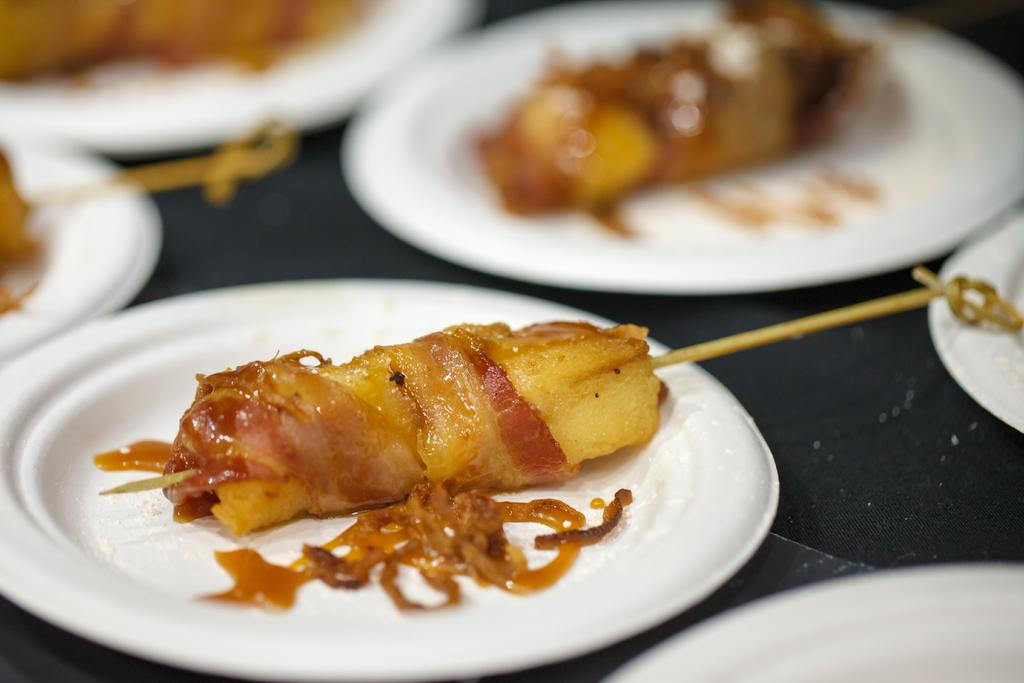What type of items can be seen in the image? There are eatables in the image. How are the eatables arranged or presented? The eatables are placed on white plates. What type of plantation can be seen in the image? There is no plantation present in the image; it features eatables placed on white plates. How does the ocean relate to the image? The image does not depict any ocean or water-related elements; it focuses on eatables placed on white plates. 